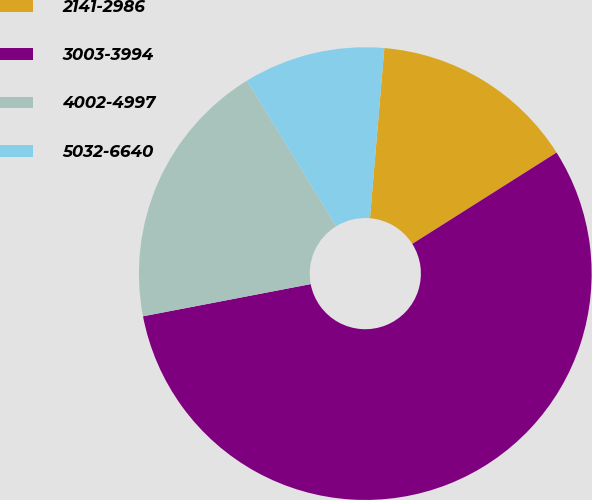Convert chart. <chart><loc_0><loc_0><loc_500><loc_500><pie_chart><fcel>2141-2986<fcel>3003-3994<fcel>4002-4997<fcel>5032-6640<nl><fcel>14.68%<fcel>55.96%<fcel>19.27%<fcel>10.09%<nl></chart> 